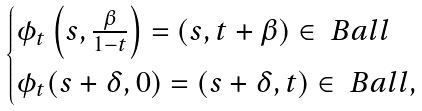<formula> <loc_0><loc_0><loc_500><loc_500>\begin{cases} \phi _ { t } \left ( s , \frac { \beta } { 1 - t } \right ) = ( s , t + \beta ) \in \ B a l l \\ \phi _ { t } ( s + \delta , 0 ) = ( s + \delta , t ) \in \ B a l l , \\ \end{cases}</formula> 